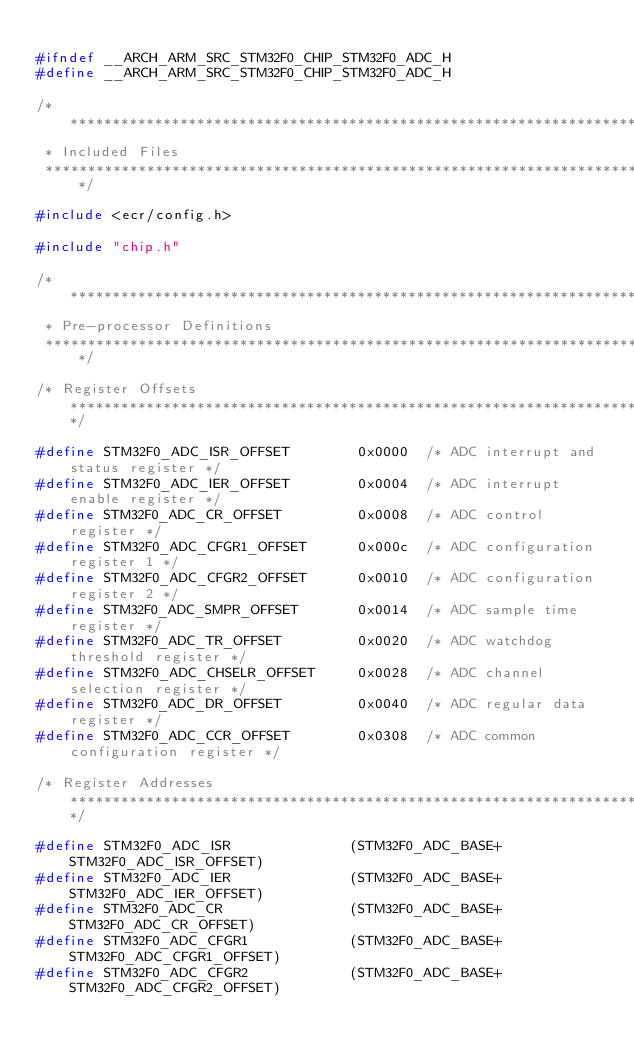Convert code to text. <code><loc_0><loc_0><loc_500><loc_500><_C_>
#ifndef __ARCH_ARM_SRC_STM32F0_CHIP_STM32F0_ADC_H
#define __ARCH_ARM_SRC_STM32F0_CHIP_STM32F0_ADC_H

/********************************************************************************
 * Included Files
 ********************************************************************************/

#include <ecr/config.h>

#include "chip.h"

/********************************************************************************
 * Pre-processor Definitions
 ********************************************************************************/

/* Register Offsets *********************************************************************************/

#define STM32F0_ADC_ISR_OFFSET        0x0000  /* ADC interrupt and status register */
#define STM32F0_ADC_IER_OFFSET        0x0004  /* ADC interrupt enable register */
#define STM32F0_ADC_CR_OFFSET         0x0008  /* ADC control register */
#define STM32F0_ADC_CFGR1_OFFSET      0x000c  /* ADC configuration register 1 */
#define STM32F0_ADC_CFGR2_OFFSET      0x0010  /* ADC configuration register 2 */
#define STM32F0_ADC_SMPR_OFFSET       0x0014  /* ADC sample time register */
#define STM32F0_ADC_TR_OFFSET         0x0020  /* ADC watchdog threshold register */
#define STM32F0_ADC_CHSELR_OFFSET     0x0028  /* ADC channel selection register */
#define STM32F0_ADC_DR_OFFSET         0x0040  /* ADC regular data register */
#define STM32F0_ADC_CCR_OFFSET        0x0308  /* ADC common configuration register */

/* Register Addresses *******************************************************************************/

#define STM32F0_ADC_ISR              (STM32F0_ADC_BASE+STM32F0_ADC_ISR_OFFSET)
#define STM32F0_ADC_IER              (STM32F0_ADC_BASE+STM32F0_ADC_IER_OFFSET)
#define STM32F0_ADC_CR               (STM32F0_ADC_BASE+STM32F0_ADC_CR_OFFSET)
#define STM32F0_ADC_CFGR1            (STM32F0_ADC_BASE+STM32F0_ADC_CFGR1_OFFSET)
#define STM32F0_ADC_CFGR2            (STM32F0_ADC_BASE+STM32F0_ADC_CFGR2_OFFSET)</code> 